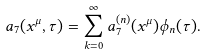<formula> <loc_0><loc_0><loc_500><loc_500>a _ { 7 } ( x ^ { \mu } , \tau ) = \sum _ { k = 0 } ^ { \infty } a _ { 7 } ^ { ( n ) } ( x ^ { \mu } ) \phi _ { n } ( \tau ) .</formula> 